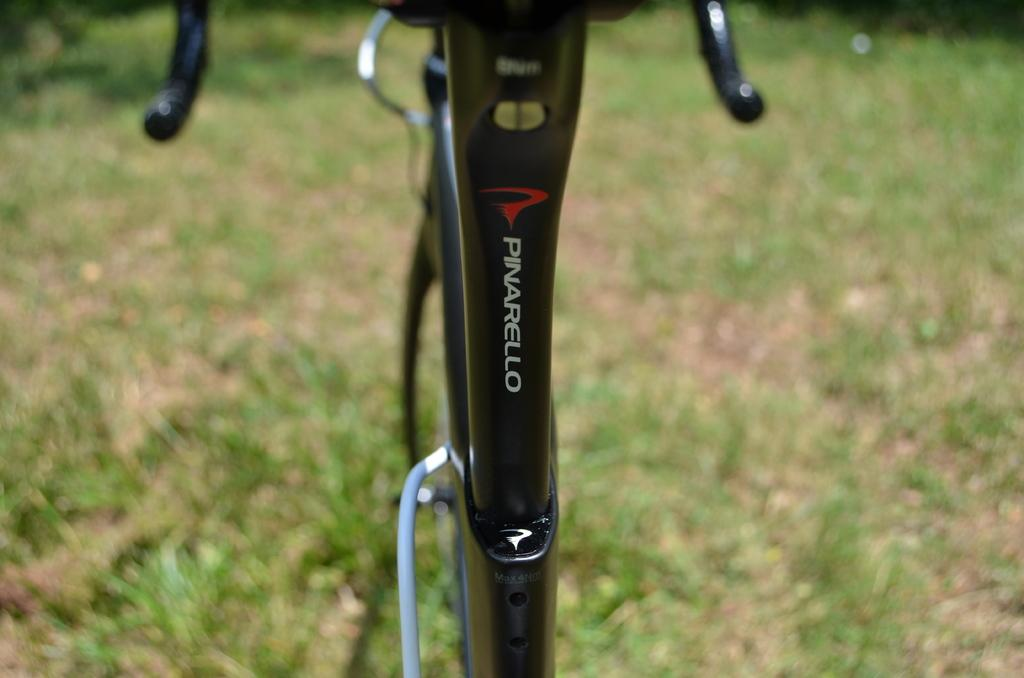Where was the picture taken? The picture was taken outside. What is the main object in the center of the image? There is a black color metal object in the center of the image, which appears to be a bicycle. What can be seen in the background of the image? The ground and green grass are visible in the background of the image. Is there a stranger standing next to the appliance in the image? There is no appliance or stranger present in the image. 